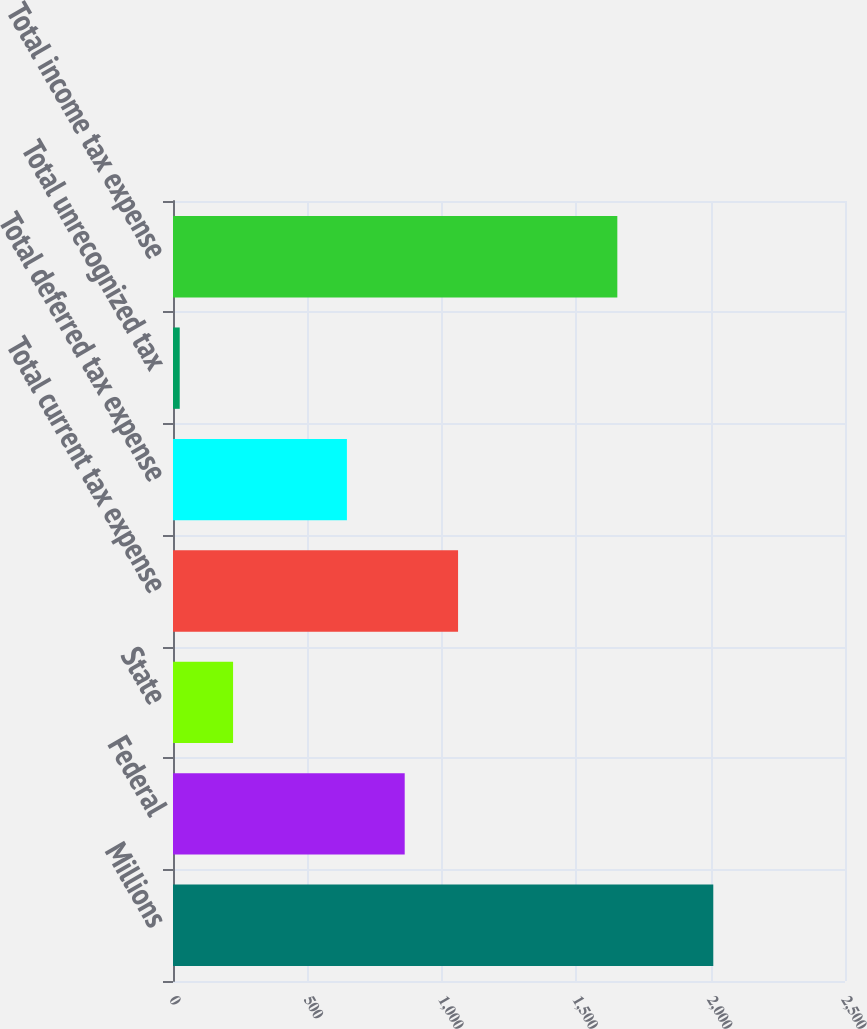<chart> <loc_0><loc_0><loc_500><loc_500><bar_chart><fcel>Millions<fcel>Federal<fcel>State<fcel>Total current tax expense<fcel>Total deferred tax expense<fcel>Total unrecognized tax<fcel>Total income tax expense<nl><fcel>2010<fcel>862<fcel>223.5<fcel>1060.5<fcel>647<fcel>25<fcel>1653<nl></chart> 